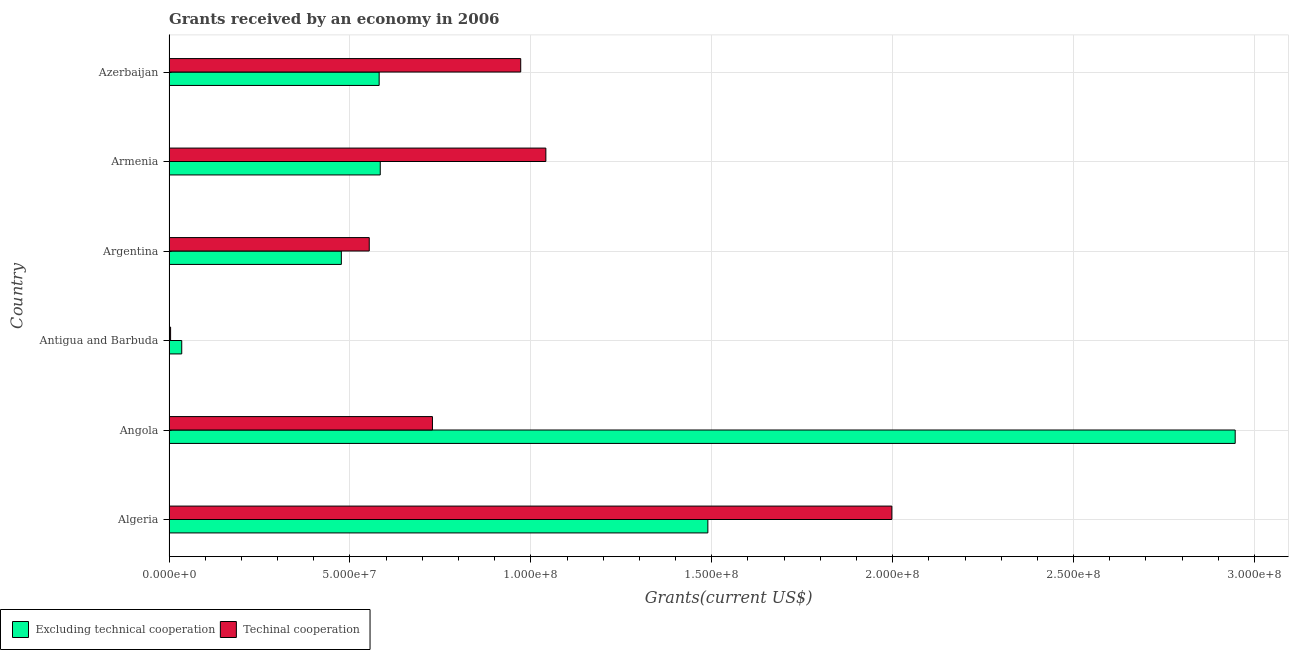Are the number of bars per tick equal to the number of legend labels?
Give a very brief answer. Yes. Are the number of bars on each tick of the Y-axis equal?
Ensure brevity in your answer.  Yes. How many bars are there on the 3rd tick from the bottom?
Give a very brief answer. 2. In how many cases, is the number of bars for a given country not equal to the number of legend labels?
Your answer should be very brief. 0. What is the amount of grants received(excluding technical cooperation) in Angola?
Offer a terse response. 2.95e+08. Across all countries, what is the maximum amount of grants received(excluding technical cooperation)?
Your answer should be compact. 2.95e+08. Across all countries, what is the minimum amount of grants received(including technical cooperation)?
Ensure brevity in your answer.  4.40e+05. In which country was the amount of grants received(excluding technical cooperation) maximum?
Your response must be concise. Angola. In which country was the amount of grants received(including technical cooperation) minimum?
Ensure brevity in your answer.  Antigua and Barbuda. What is the total amount of grants received(including technical cooperation) in the graph?
Provide a short and direct response. 5.30e+08. What is the difference between the amount of grants received(excluding technical cooperation) in Algeria and that in Armenia?
Your answer should be compact. 9.05e+07. What is the difference between the amount of grants received(excluding technical cooperation) in Argentina and the amount of grants received(including technical cooperation) in Armenia?
Offer a terse response. -5.65e+07. What is the average amount of grants received(excluding technical cooperation) per country?
Offer a very short reply. 1.02e+08. What is the difference between the amount of grants received(including technical cooperation) and amount of grants received(excluding technical cooperation) in Armenia?
Make the answer very short. 4.58e+07. What is the ratio of the amount of grants received(including technical cooperation) in Algeria to that in Argentina?
Offer a terse response. 3.61. Is the amount of grants received(including technical cooperation) in Algeria less than that in Azerbaijan?
Offer a terse response. No. Is the difference between the amount of grants received(excluding technical cooperation) in Algeria and Armenia greater than the difference between the amount of grants received(including technical cooperation) in Algeria and Armenia?
Offer a terse response. No. What is the difference between the highest and the second highest amount of grants received(including technical cooperation)?
Offer a very short reply. 9.56e+07. What is the difference between the highest and the lowest amount of grants received(excluding technical cooperation)?
Your answer should be compact. 2.91e+08. Is the sum of the amount of grants received(excluding technical cooperation) in Armenia and Azerbaijan greater than the maximum amount of grants received(including technical cooperation) across all countries?
Provide a succinct answer. No. What does the 2nd bar from the top in Angola represents?
Ensure brevity in your answer.  Excluding technical cooperation. What does the 1st bar from the bottom in Algeria represents?
Offer a very short reply. Excluding technical cooperation. How many bars are there?
Provide a short and direct response. 12. What is the difference between two consecutive major ticks on the X-axis?
Your response must be concise. 5.00e+07. Does the graph contain grids?
Offer a terse response. Yes. Where does the legend appear in the graph?
Your answer should be very brief. Bottom left. How many legend labels are there?
Provide a short and direct response. 2. How are the legend labels stacked?
Keep it short and to the point. Horizontal. What is the title of the graph?
Your answer should be compact. Grants received by an economy in 2006. What is the label or title of the X-axis?
Ensure brevity in your answer.  Grants(current US$). What is the label or title of the Y-axis?
Your answer should be very brief. Country. What is the Grants(current US$) of Excluding technical cooperation in Algeria?
Provide a short and direct response. 1.49e+08. What is the Grants(current US$) of Techinal cooperation in Algeria?
Your answer should be very brief. 2.00e+08. What is the Grants(current US$) of Excluding technical cooperation in Angola?
Give a very brief answer. 2.95e+08. What is the Grants(current US$) in Techinal cooperation in Angola?
Offer a terse response. 7.28e+07. What is the Grants(current US$) in Excluding technical cooperation in Antigua and Barbuda?
Your response must be concise. 3.52e+06. What is the Grants(current US$) in Excluding technical cooperation in Argentina?
Provide a succinct answer. 4.76e+07. What is the Grants(current US$) in Techinal cooperation in Argentina?
Make the answer very short. 5.53e+07. What is the Grants(current US$) of Excluding technical cooperation in Armenia?
Ensure brevity in your answer.  5.84e+07. What is the Grants(current US$) of Techinal cooperation in Armenia?
Provide a succinct answer. 1.04e+08. What is the Grants(current US$) in Excluding technical cooperation in Azerbaijan?
Provide a succinct answer. 5.81e+07. What is the Grants(current US$) in Techinal cooperation in Azerbaijan?
Keep it short and to the point. 9.72e+07. Across all countries, what is the maximum Grants(current US$) in Excluding technical cooperation?
Offer a terse response. 2.95e+08. Across all countries, what is the maximum Grants(current US$) in Techinal cooperation?
Your response must be concise. 2.00e+08. Across all countries, what is the minimum Grants(current US$) in Excluding technical cooperation?
Ensure brevity in your answer.  3.52e+06. Across all countries, what is the minimum Grants(current US$) in Techinal cooperation?
Your answer should be compact. 4.40e+05. What is the total Grants(current US$) of Excluding technical cooperation in the graph?
Your answer should be very brief. 6.11e+08. What is the total Grants(current US$) in Techinal cooperation in the graph?
Your answer should be very brief. 5.30e+08. What is the difference between the Grants(current US$) of Excluding technical cooperation in Algeria and that in Angola?
Give a very brief answer. -1.46e+08. What is the difference between the Grants(current US$) in Techinal cooperation in Algeria and that in Angola?
Give a very brief answer. 1.27e+08. What is the difference between the Grants(current US$) of Excluding technical cooperation in Algeria and that in Antigua and Barbuda?
Offer a very short reply. 1.45e+08. What is the difference between the Grants(current US$) of Techinal cooperation in Algeria and that in Antigua and Barbuda?
Provide a short and direct response. 1.99e+08. What is the difference between the Grants(current US$) in Excluding technical cooperation in Algeria and that in Argentina?
Ensure brevity in your answer.  1.01e+08. What is the difference between the Grants(current US$) of Techinal cooperation in Algeria and that in Argentina?
Keep it short and to the point. 1.44e+08. What is the difference between the Grants(current US$) of Excluding technical cooperation in Algeria and that in Armenia?
Your answer should be compact. 9.05e+07. What is the difference between the Grants(current US$) of Techinal cooperation in Algeria and that in Armenia?
Provide a short and direct response. 9.56e+07. What is the difference between the Grants(current US$) in Excluding technical cooperation in Algeria and that in Azerbaijan?
Your answer should be compact. 9.08e+07. What is the difference between the Grants(current US$) of Techinal cooperation in Algeria and that in Azerbaijan?
Keep it short and to the point. 1.03e+08. What is the difference between the Grants(current US$) in Excluding technical cooperation in Angola and that in Antigua and Barbuda?
Your answer should be compact. 2.91e+08. What is the difference between the Grants(current US$) in Techinal cooperation in Angola and that in Antigua and Barbuda?
Your response must be concise. 7.24e+07. What is the difference between the Grants(current US$) in Excluding technical cooperation in Angola and that in Argentina?
Your answer should be very brief. 2.47e+08. What is the difference between the Grants(current US$) in Techinal cooperation in Angola and that in Argentina?
Offer a very short reply. 1.75e+07. What is the difference between the Grants(current US$) of Excluding technical cooperation in Angola and that in Armenia?
Offer a very short reply. 2.36e+08. What is the difference between the Grants(current US$) in Techinal cooperation in Angola and that in Armenia?
Make the answer very short. -3.13e+07. What is the difference between the Grants(current US$) of Excluding technical cooperation in Angola and that in Azerbaijan?
Offer a very short reply. 2.37e+08. What is the difference between the Grants(current US$) of Techinal cooperation in Angola and that in Azerbaijan?
Provide a short and direct response. -2.44e+07. What is the difference between the Grants(current US$) of Excluding technical cooperation in Antigua and Barbuda and that in Argentina?
Your answer should be very brief. -4.41e+07. What is the difference between the Grants(current US$) of Techinal cooperation in Antigua and Barbuda and that in Argentina?
Your answer should be compact. -5.49e+07. What is the difference between the Grants(current US$) in Excluding technical cooperation in Antigua and Barbuda and that in Armenia?
Your response must be concise. -5.49e+07. What is the difference between the Grants(current US$) of Techinal cooperation in Antigua and Barbuda and that in Armenia?
Make the answer very short. -1.04e+08. What is the difference between the Grants(current US$) in Excluding technical cooperation in Antigua and Barbuda and that in Azerbaijan?
Offer a very short reply. -5.46e+07. What is the difference between the Grants(current US$) of Techinal cooperation in Antigua and Barbuda and that in Azerbaijan?
Ensure brevity in your answer.  -9.68e+07. What is the difference between the Grants(current US$) in Excluding technical cooperation in Argentina and that in Armenia?
Provide a succinct answer. -1.08e+07. What is the difference between the Grants(current US$) of Techinal cooperation in Argentina and that in Armenia?
Your answer should be compact. -4.88e+07. What is the difference between the Grants(current US$) of Excluding technical cooperation in Argentina and that in Azerbaijan?
Make the answer very short. -1.04e+07. What is the difference between the Grants(current US$) of Techinal cooperation in Argentina and that in Azerbaijan?
Make the answer very short. -4.19e+07. What is the difference between the Grants(current US$) of Excluding technical cooperation in Armenia and that in Azerbaijan?
Provide a succinct answer. 3.00e+05. What is the difference between the Grants(current US$) of Techinal cooperation in Armenia and that in Azerbaijan?
Make the answer very short. 6.95e+06. What is the difference between the Grants(current US$) in Excluding technical cooperation in Algeria and the Grants(current US$) in Techinal cooperation in Angola?
Give a very brief answer. 7.61e+07. What is the difference between the Grants(current US$) of Excluding technical cooperation in Algeria and the Grants(current US$) of Techinal cooperation in Antigua and Barbuda?
Keep it short and to the point. 1.48e+08. What is the difference between the Grants(current US$) of Excluding technical cooperation in Algeria and the Grants(current US$) of Techinal cooperation in Argentina?
Make the answer very short. 9.36e+07. What is the difference between the Grants(current US$) of Excluding technical cooperation in Algeria and the Grants(current US$) of Techinal cooperation in Armenia?
Give a very brief answer. 4.48e+07. What is the difference between the Grants(current US$) of Excluding technical cooperation in Algeria and the Grants(current US$) of Techinal cooperation in Azerbaijan?
Offer a terse response. 5.17e+07. What is the difference between the Grants(current US$) in Excluding technical cooperation in Angola and the Grants(current US$) in Techinal cooperation in Antigua and Barbuda?
Your answer should be very brief. 2.94e+08. What is the difference between the Grants(current US$) of Excluding technical cooperation in Angola and the Grants(current US$) of Techinal cooperation in Argentina?
Your answer should be very brief. 2.39e+08. What is the difference between the Grants(current US$) in Excluding technical cooperation in Angola and the Grants(current US$) in Techinal cooperation in Armenia?
Offer a very short reply. 1.90e+08. What is the difference between the Grants(current US$) in Excluding technical cooperation in Angola and the Grants(current US$) in Techinal cooperation in Azerbaijan?
Your answer should be compact. 1.97e+08. What is the difference between the Grants(current US$) of Excluding technical cooperation in Antigua and Barbuda and the Grants(current US$) of Techinal cooperation in Argentina?
Offer a very short reply. -5.18e+07. What is the difference between the Grants(current US$) of Excluding technical cooperation in Antigua and Barbuda and the Grants(current US$) of Techinal cooperation in Armenia?
Your answer should be compact. -1.01e+08. What is the difference between the Grants(current US$) of Excluding technical cooperation in Antigua and Barbuda and the Grants(current US$) of Techinal cooperation in Azerbaijan?
Ensure brevity in your answer.  -9.37e+07. What is the difference between the Grants(current US$) in Excluding technical cooperation in Argentina and the Grants(current US$) in Techinal cooperation in Armenia?
Give a very brief answer. -5.65e+07. What is the difference between the Grants(current US$) in Excluding technical cooperation in Argentina and the Grants(current US$) in Techinal cooperation in Azerbaijan?
Provide a short and direct response. -4.96e+07. What is the difference between the Grants(current US$) of Excluding technical cooperation in Armenia and the Grants(current US$) of Techinal cooperation in Azerbaijan?
Give a very brief answer. -3.88e+07. What is the average Grants(current US$) of Excluding technical cooperation per country?
Your answer should be very brief. 1.02e+08. What is the average Grants(current US$) of Techinal cooperation per country?
Give a very brief answer. 8.83e+07. What is the difference between the Grants(current US$) in Excluding technical cooperation and Grants(current US$) in Techinal cooperation in Algeria?
Your response must be concise. -5.08e+07. What is the difference between the Grants(current US$) in Excluding technical cooperation and Grants(current US$) in Techinal cooperation in Angola?
Your response must be concise. 2.22e+08. What is the difference between the Grants(current US$) of Excluding technical cooperation and Grants(current US$) of Techinal cooperation in Antigua and Barbuda?
Your answer should be very brief. 3.08e+06. What is the difference between the Grants(current US$) of Excluding technical cooperation and Grants(current US$) of Techinal cooperation in Argentina?
Your answer should be compact. -7.71e+06. What is the difference between the Grants(current US$) of Excluding technical cooperation and Grants(current US$) of Techinal cooperation in Armenia?
Your answer should be compact. -4.58e+07. What is the difference between the Grants(current US$) of Excluding technical cooperation and Grants(current US$) of Techinal cooperation in Azerbaijan?
Your answer should be compact. -3.91e+07. What is the ratio of the Grants(current US$) in Excluding technical cooperation in Algeria to that in Angola?
Your response must be concise. 0.51. What is the ratio of the Grants(current US$) in Techinal cooperation in Algeria to that in Angola?
Your response must be concise. 2.74. What is the ratio of the Grants(current US$) in Excluding technical cooperation in Algeria to that in Antigua and Barbuda?
Provide a succinct answer. 42.31. What is the ratio of the Grants(current US$) in Techinal cooperation in Algeria to that in Antigua and Barbuda?
Provide a succinct answer. 454.02. What is the ratio of the Grants(current US$) of Excluding technical cooperation in Algeria to that in Argentina?
Provide a succinct answer. 3.13. What is the ratio of the Grants(current US$) in Techinal cooperation in Algeria to that in Argentina?
Provide a succinct answer. 3.61. What is the ratio of the Grants(current US$) in Excluding technical cooperation in Algeria to that in Armenia?
Provide a succinct answer. 2.55. What is the ratio of the Grants(current US$) in Techinal cooperation in Algeria to that in Armenia?
Your answer should be very brief. 1.92. What is the ratio of the Grants(current US$) in Excluding technical cooperation in Algeria to that in Azerbaijan?
Ensure brevity in your answer.  2.56. What is the ratio of the Grants(current US$) in Techinal cooperation in Algeria to that in Azerbaijan?
Your response must be concise. 2.06. What is the ratio of the Grants(current US$) of Excluding technical cooperation in Angola to that in Antigua and Barbuda?
Provide a short and direct response. 83.71. What is the ratio of the Grants(current US$) of Techinal cooperation in Angola to that in Antigua and Barbuda?
Your answer should be compact. 165.48. What is the ratio of the Grants(current US$) of Excluding technical cooperation in Angola to that in Argentina?
Your response must be concise. 6.19. What is the ratio of the Grants(current US$) of Techinal cooperation in Angola to that in Argentina?
Give a very brief answer. 1.32. What is the ratio of the Grants(current US$) of Excluding technical cooperation in Angola to that in Armenia?
Offer a terse response. 5.05. What is the ratio of the Grants(current US$) in Techinal cooperation in Angola to that in Armenia?
Your answer should be compact. 0.7. What is the ratio of the Grants(current US$) in Excluding technical cooperation in Angola to that in Azerbaijan?
Make the answer very short. 5.07. What is the ratio of the Grants(current US$) in Techinal cooperation in Angola to that in Azerbaijan?
Keep it short and to the point. 0.75. What is the ratio of the Grants(current US$) in Excluding technical cooperation in Antigua and Barbuda to that in Argentina?
Provide a succinct answer. 0.07. What is the ratio of the Grants(current US$) of Techinal cooperation in Antigua and Barbuda to that in Argentina?
Your response must be concise. 0.01. What is the ratio of the Grants(current US$) of Excluding technical cooperation in Antigua and Barbuda to that in Armenia?
Your answer should be very brief. 0.06. What is the ratio of the Grants(current US$) of Techinal cooperation in Antigua and Barbuda to that in Armenia?
Ensure brevity in your answer.  0. What is the ratio of the Grants(current US$) of Excluding technical cooperation in Antigua and Barbuda to that in Azerbaijan?
Make the answer very short. 0.06. What is the ratio of the Grants(current US$) in Techinal cooperation in Antigua and Barbuda to that in Azerbaijan?
Keep it short and to the point. 0. What is the ratio of the Grants(current US$) of Excluding technical cooperation in Argentina to that in Armenia?
Make the answer very short. 0.82. What is the ratio of the Grants(current US$) in Techinal cooperation in Argentina to that in Armenia?
Your response must be concise. 0.53. What is the ratio of the Grants(current US$) in Excluding technical cooperation in Argentina to that in Azerbaijan?
Your response must be concise. 0.82. What is the ratio of the Grants(current US$) of Techinal cooperation in Argentina to that in Azerbaijan?
Provide a short and direct response. 0.57. What is the ratio of the Grants(current US$) of Techinal cooperation in Armenia to that in Azerbaijan?
Provide a short and direct response. 1.07. What is the difference between the highest and the second highest Grants(current US$) in Excluding technical cooperation?
Ensure brevity in your answer.  1.46e+08. What is the difference between the highest and the second highest Grants(current US$) of Techinal cooperation?
Provide a succinct answer. 9.56e+07. What is the difference between the highest and the lowest Grants(current US$) of Excluding technical cooperation?
Your answer should be very brief. 2.91e+08. What is the difference between the highest and the lowest Grants(current US$) in Techinal cooperation?
Your answer should be very brief. 1.99e+08. 